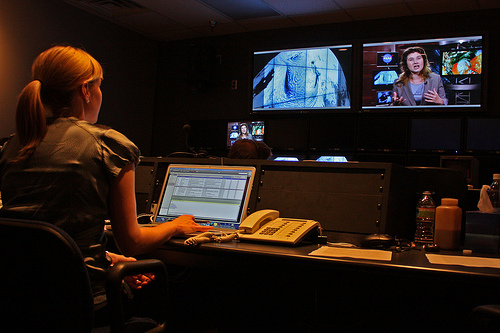Is it common to have multiple screens in this type of work environment? Yes, it's quite common. Multiple screens allow video editors and producers to view different angles, shots, and timelines simultaneously, which is imperative for effective editing and production work. It helps streamline the process and ensures attention to detail. 